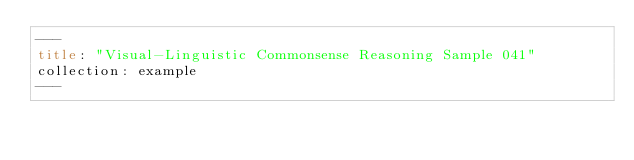Convert code to text. <code><loc_0><loc_0><loc_500><loc_500><_HTML_>---
title: "Visual-Linguistic Commonsense Reasoning Sample 041"
collection: example
---
</code> 